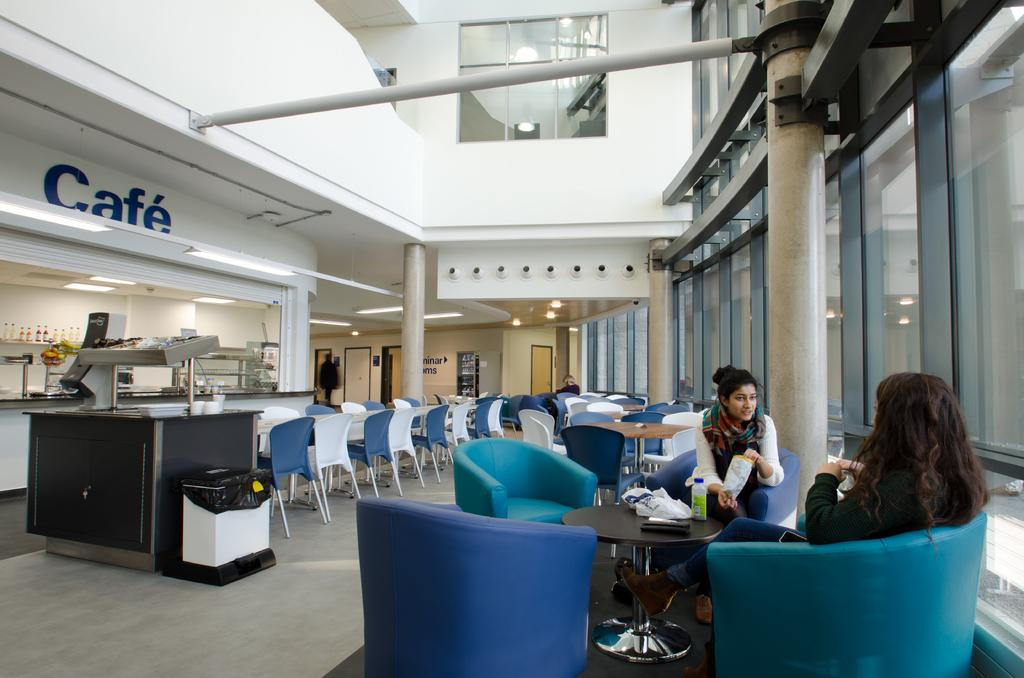How many people are in the image? There are two women in the image. Where are the women located in the image? The women are sitting in a coffee shop. What are the women doing in the image? The women are talking to each other. What type of cow can be seen grazing in the field behind the coffee shop in the image? There is no field or cow present in the image; it features two women sitting in a coffee shop. 